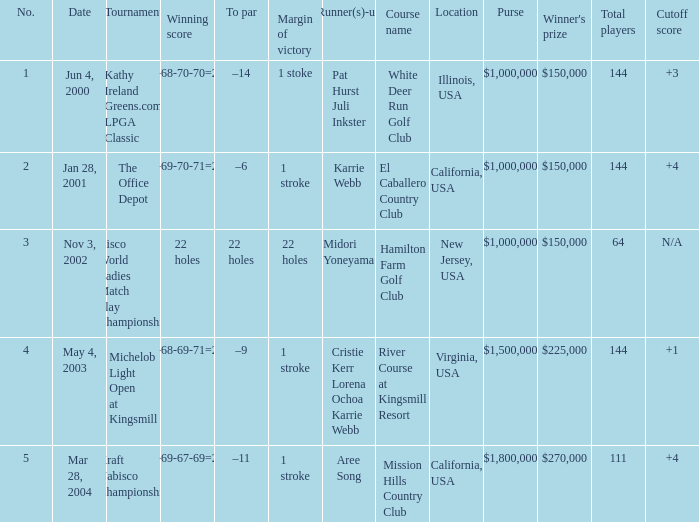Where was the tournament dated nov 3, 2002? Cisco World Ladies Match Play Championship. 